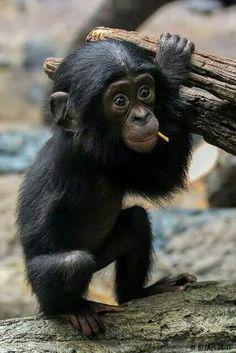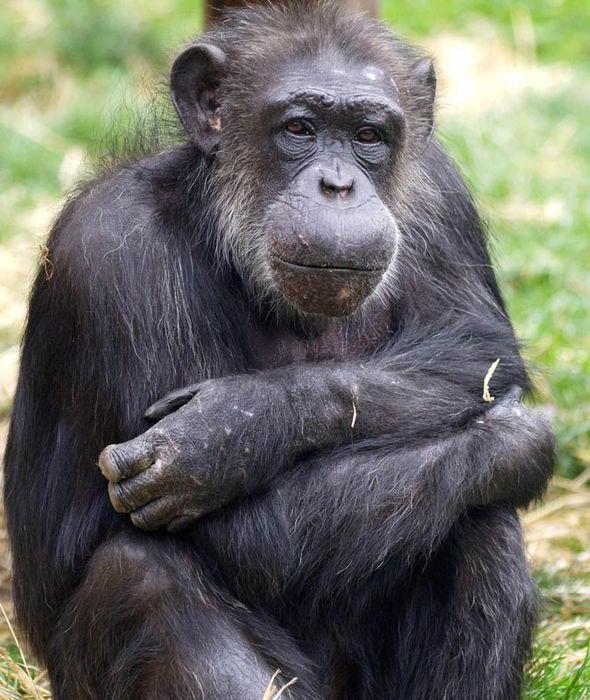The first image is the image on the left, the second image is the image on the right. Given the left and right images, does the statement "There is a baby monkey being held by its mother." hold true? Answer yes or no. No. The first image is the image on the left, the second image is the image on the right. Given the left and right images, does the statement "One chimp is holding another chimp." hold true? Answer yes or no. No. 